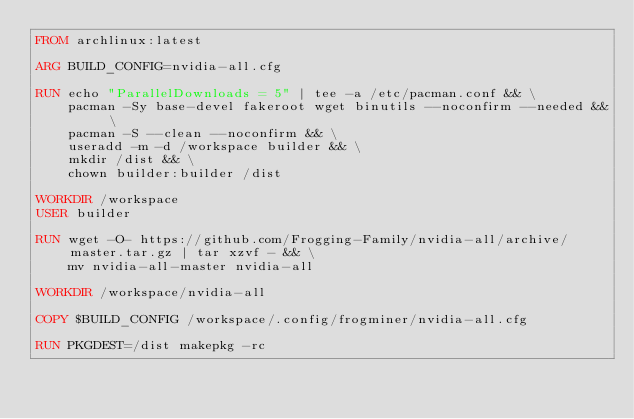Convert code to text. <code><loc_0><loc_0><loc_500><loc_500><_Dockerfile_>FROM archlinux:latest

ARG BUILD_CONFIG=nvidia-all.cfg

RUN echo "ParallelDownloads = 5" | tee -a /etc/pacman.conf && \
    pacman -Sy base-devel fakeroot wget binutils --noconfirm --needed && \
    pacman -S --clean --noconfirm && \
    useradd -m -d /workspace builder && \
    mkdir /dist && \
    chown builder:builder /dist

WORKDIR /workspace
USER builder

RUN wget -O- https://github.com/Frogging-Family/nvidia-all/archive/master.tar.gz | tar xzvf - && \
    mv nvidia-all-master nvidia-all

WORKDIR /workspace/nvidia-all

COPY $BUILD_CONFIG /workspace/.config/frogminer/nvidia-all.cfg

RUN PKGDEST=/dist makepkg -rc
</code> 